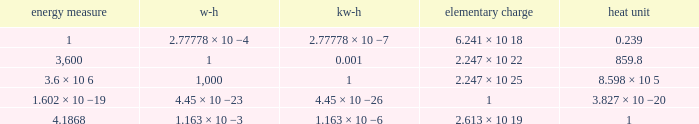Parse the full table. {'header': ['energy measure', 'w-h', 'kw-h', 'elementary charge', 'heat unit'], 'rows': [['1', '2.77778 × 10 −4', '2.77778 × 10 −7', '6.241 × 10 18', '0.239'], ['3,600', '1', '0.001', '2.247 × 10 22', '859.8'], ['3.6 × 10 6', '1,000', '1', '2.247 × 10 25', '8.598 × 10 5'], ['1.602 × 10 −19', '4.45 × 10 −23', '4.45 × 10 −26', '1', '3.827 × 10 −20'], ['4.1868', '1.163 × 10 −3', '1.163 × 10 −6', '2.613 × 10 19', '1']]} How many calories is 1 watt hour? 859.8. 